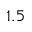<formula> <loc_0><loc_0><loc_500><loc_500>1 . 5</formula> 